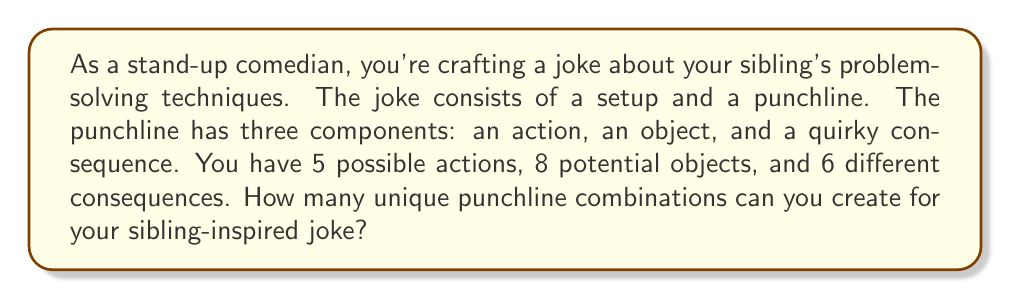Give your solution to this math problem. Let's approach this problem step-by-step using the fundamental counting principle from combinatorics:

1) We have three independent components for the punchline:
   - Actions: 5 choices
   - Objects: 8 choices
   - Consequences: 6 choices

2) According to the fundamental counting principle, if we have a series of independent choices, the total number of possible outcomes is the product of the number of possibilities for each choice.

3) Therefore, the total number of unique punchline combinations is:

   $$ \text{Total combinations} = \text{Actions} \times \text{Objects} \times \text{Consequences} $$

4) Substituting the given values:

   $$ \text{Total combinations} = 5 \times 8 \times 6 $$

5) Calculating the result:

   $$ \text{Total combinations} = 240 $$

Thus, you can create 240 unique punchline combinations for your sibling-inspired joke.
Answer: 240 